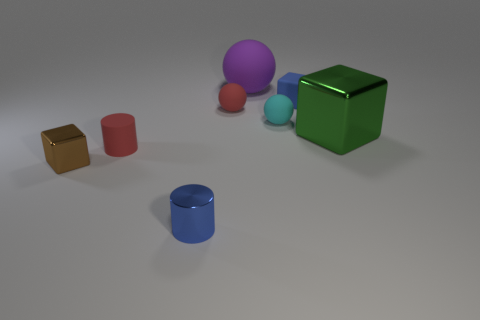Add 1 small matte blocks. How many objects exist? 9 Subtract all balls. How many objects are left? 5 Add 4 large blocks. How many large blocks are left? 5 Add 5 shiny cubes. How many shiny cubes exist? 7 Subtract 1 green cubes. How many objects are left? 7 Subtract all balls. Subtract all tiny red cylinders. How many objects are left? 4 